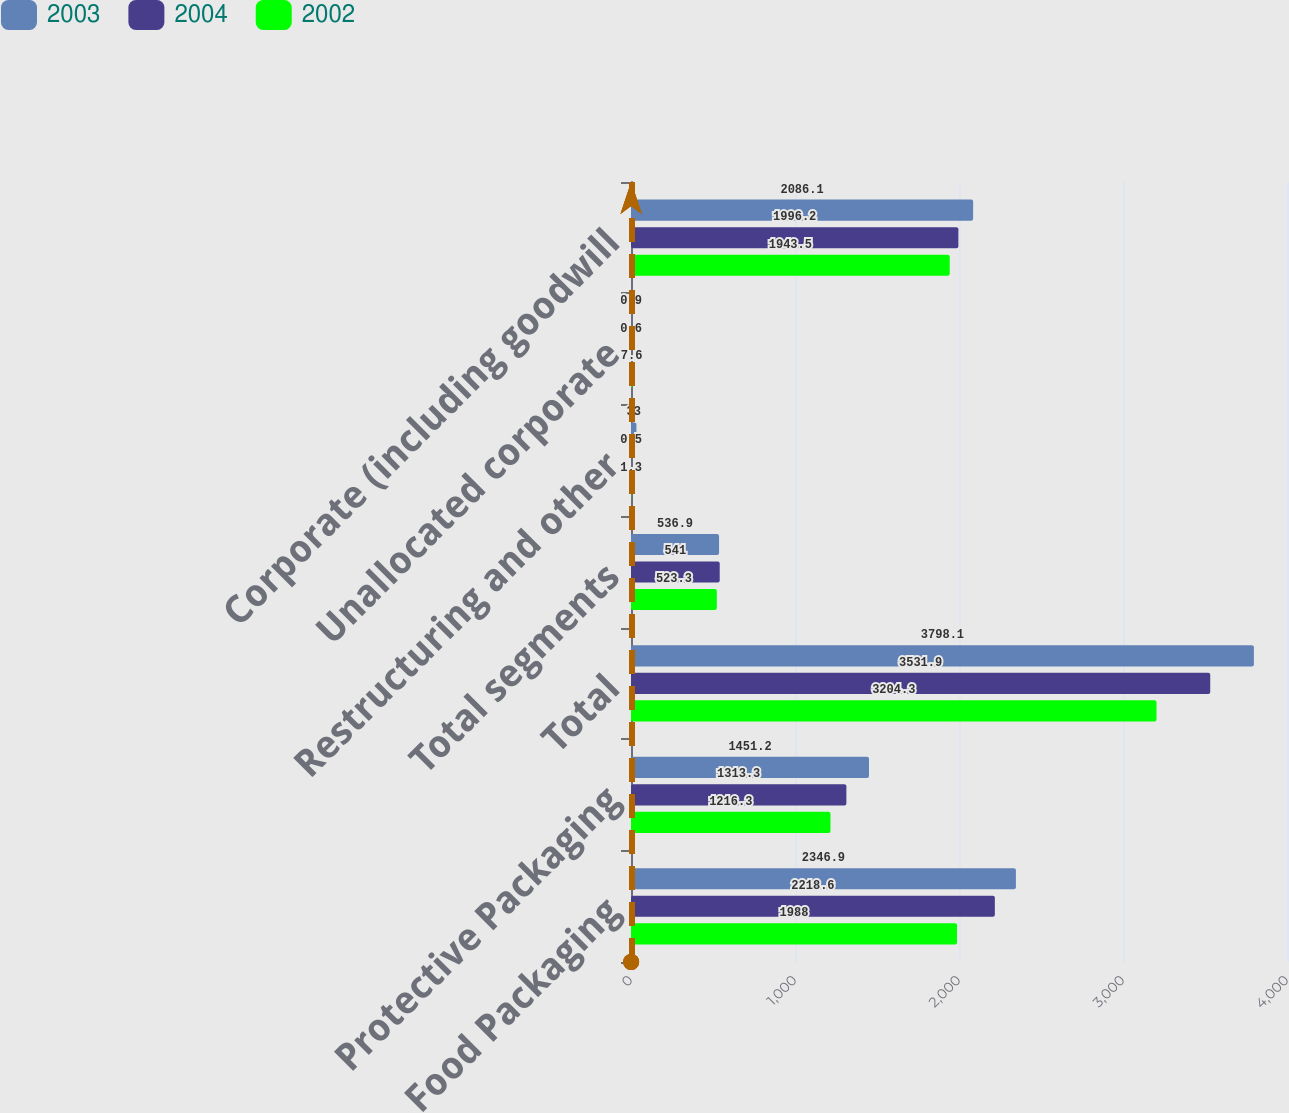<chart> <loc_0><loc_0><loc_500><loc_500><stacked_bar_chart><ecel><fcel>Food Packaging<fcel>Protective Packaging<fcel>Total<fcel>Total segments<fcel>Restructuring and other<fcel>Unallocated corporate<fcel>Corporate (including goodwill<nl><fcel>2003<fcel>2346.9<fcel>1451.2<fcel>3798.1<fcel>536.9<fcel>33<fcel>0.9<fcel>2086.1<nl><fcel>2004<fcel>2218.6<fcel>1313.3<fcel>3531.9<fcel>541<fcel>0.5<fcel>0.6<fcel>1996.2<nl><fcel>2002<fcel>1988<fcel>1216.3<fcel>3204.3<fcel>523.3<fcel>1.3<fcel>7.6<fcel>1943.5<nl></chart> 